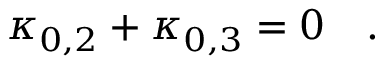<formula> <loc_0><loc_0><loc_500><loc_500>\kappa _ { 0 , 2 } + \kappa _ { 0 , 3 } = 0 \quad .</formula> 